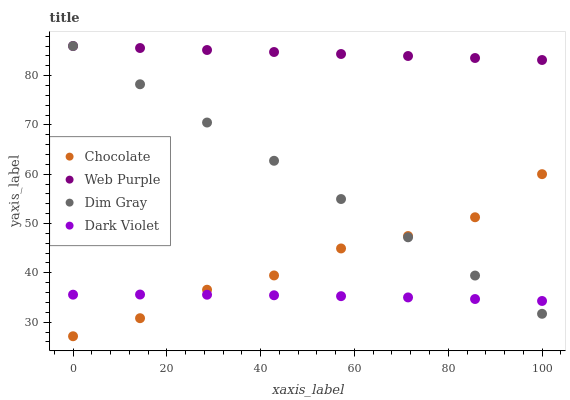Does Dark Violet have the minimum area under the curve?
Answer yes or no. Yes. Does Web Purple have the maximum area under the curve?
Answer yes or no. Yes. Does Dim Gray have the minimum area under the curve?
Answer yes or no. No. Does Dim Gray have the maximum area under the curve?
Answer yes or no. No. Is Dim Gray the smoothest?
Answer yes or no. Yes. Is Chocolate the roughest?
Answer yes or no. Yes. Is Dark Violet the smoothest?
Answer yes or no. No. Is Dark Violet the roughest?
Answer yes or no. No. Does Chocolate have the lowest value?
Answer yes or no. Yes. Does Dim Gray have the lowest value?
Answer yes or no. No. Does Dim Gray have the highest value?
Answer yes or no. Yes. Does Dark Violet have the highest value?
Answer yes or no. No. Is Dark Violet less than Web Purple?
Answer yes or no. Yes. Is Web Purple greater than Dark Violet?
Answer yes or no. Yes. Does Dark Violet intersect Dim Gray?
Answer yes or no. Yes. Is Dark Violet less than Dim Gray?
Answer yes or no. No. Is Dark Violet greater than Dim Gray?
Answer yes or no. No. Does Dark Violet intersect Web Purple?
Answer yes or no. No. 